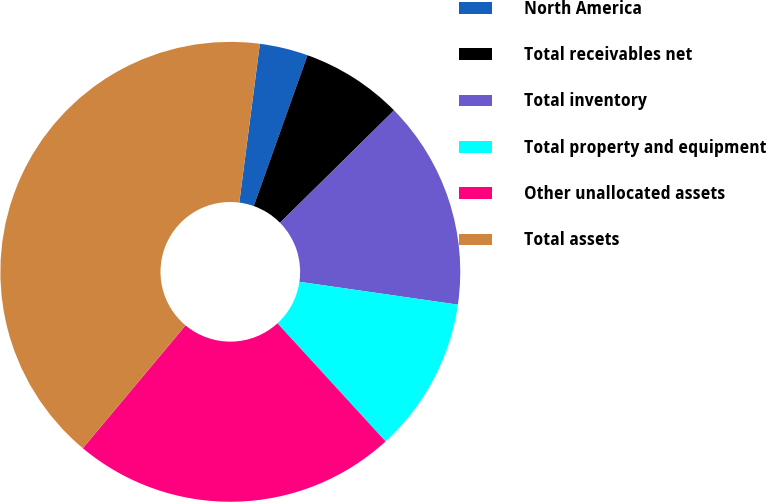Convert chart to OTSL. <chart><loc_0><loc_0><loc_500><loc_500><pie_chart><fcel>North America<fcel>Total receivables net<fcel>Total inventory<fcel>Total property and equipment<fcel>Other unallocated assets<fcel>Total assets<nl><fcel>3.4%<fcel>7.16%<fcel>14.67%<fcel>10.92%<fcel>22.88%<fcel>40.97%<nl></chart> 